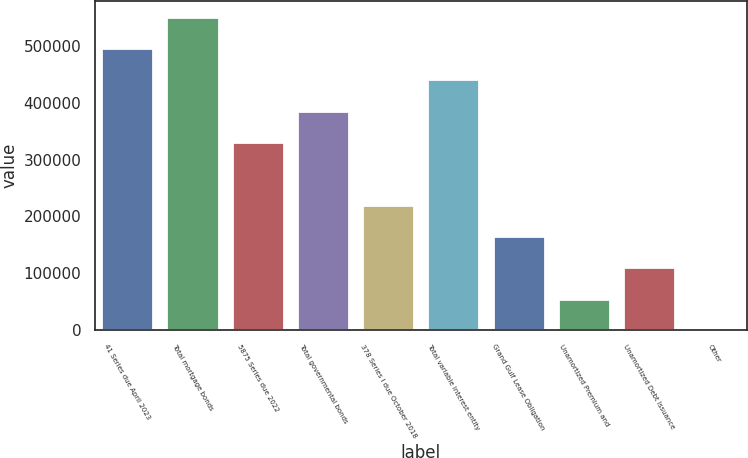<chart> <loc_0><loc_0><loc_500><loc_500><bar_chart><fcel>41 Series due April 2023<fcel>Total mortgage bonds<fcel>5875 Series due 2022<fcel>Total governmental bonds<fcel>378 Series I due October 2018<fcel>Total variable interest entity<fcel>Grand Gulf Lease Obligation<fcel>Unamortized Premium and<fcel>Unamortized Debt Issuance<fcel>Other<nl><fcel>496339<fcel>551488<fcel>330894<fcel>386042<fcel>220596<fcel>441191<fcel>165448<fcel>55150.6<fcel>110299<fcel>2<nl></chart> 